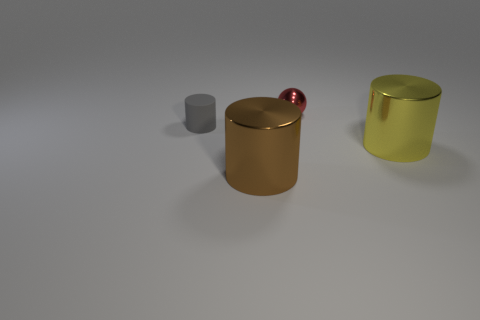Is the large object that is on the left side of the small ball made of the same material as the thing that is left of the brown object?
Your response must be concise. No. How big is the shiny object that is to the right of the small thing right of the gray cylinder?
Keep it short and to the point. Large. Is there anything else that is the same size as the rubber cylinder?
Provide a succinct answer. Yes. There is another tiny object that is the same shape as the brown thing; what is it made of?
Offer a very short reply. Rubber. There is a small thing that is in front of the small red metal sphere; is its shape the same as the tiny object that is right of the brown cylinder?
Your answer should be very brief. No. Are there more small blue cubes than tiny gray things?
Keep it short and to the point. No. The rubber cylinder is what size?
Your response must be concise. Small. How many other objects are there of the same color as the tiny matte cylinder?
Keep it short and to the point. 0. Is the material of the object behind the gray matte thing the same as the yellow cylinder?
Provide a short and direct response. Yes. Is the number of tiny gray things to the left of the tiny gray matte thing less than the number of large brown metallic cylinders that are right of the yellow metal thing?
Provide a succinct answer. No. 